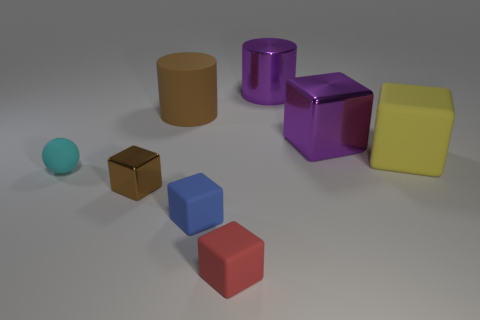Is there a tiny cyan sphere?
Provide a succinct answer. Yes. Are there the same number of blue matte cubes that are to the left of the tiny cyan ball and small objects?
Your answer should be very brief. No. What number of other things are the same shape as the small metal thing?
Your answer should be very brief. 4. What shape is the brown shiny thing?
Your answer should be compact. Cube. Does the yellow thing have the same material as the large purple block?
Ensure brevity in your answer.  No. Is the number of purple objects that are to the left of the tiny brown metallic thing the same as the number of big cubes on the left side of the yellow matte object?
Your answer should be compact. No. There is a shiny object to the left of the matte block that is in front of the blue matte block; is there a large object in front of it?
Ensure brevity in your answer.  No. Do the red object and the rubber ball have the same size?
Keep it short and to the point. Yes. What color is the rubber thing that is behind the big purple object in front of the large purple object behind the purple metal cube?
Provide a short and direct response. Brown. What number of large metallic things have the same color as the large shiny cube?
Make the answer very short. 1. 